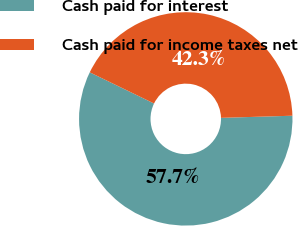Convert chart. <chart><loc_0><loc_0><loc_500><loc_500><pie_chart><fcel>Cash paid for interest<fcel>Cash paid for income taxes net<nl><fcel>57.66%<fcel>42.34%<nl></chart> 